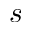Convert formula to latex. <formula><loc_0><loc_0><loc_500><loc_500>s</formula> 